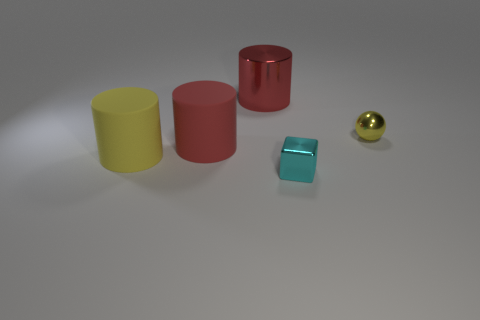What material is the red cylinder that is the same size as the red shiny object?
Your answer should be very brief. Rubber. What number of other big cylinders have the same material as the yellow cylinder?
Ensure brevity in your answer.  1. Is the size of the red object that is to the left of the large metallic object the same as the yellow thing to the right of the big red metallic cylinder?
Give a very brief answer. No. The small shiny thing that is to the right of the cube is what color?
Keep it short and to the point. Yellow. What number of small metal things are the same color as the large metal cylinder?
Your answer should be very brief. 0. There is a sphere; does it have the same size as the red thing in front of the metallic cylinder?
Ensure brevity in your answer.  No. There is a rubber object on the right side of the cylinder in front of the large red cylinder that is in front of the big red metallic cylinder; what size is it?
Offer a terse response. Large. There is a tiny cyan metallic thing; what number of small blocks are in front of it?
Offer a terse response. 0. What is the material of the big object that is on the right side of the red cylinder on the left side of the red shiny thing?
Your answer should be compact. Metal. Do the metal sphere and the cyan thing have the same size?
Provide a succinct answer. Yes. 